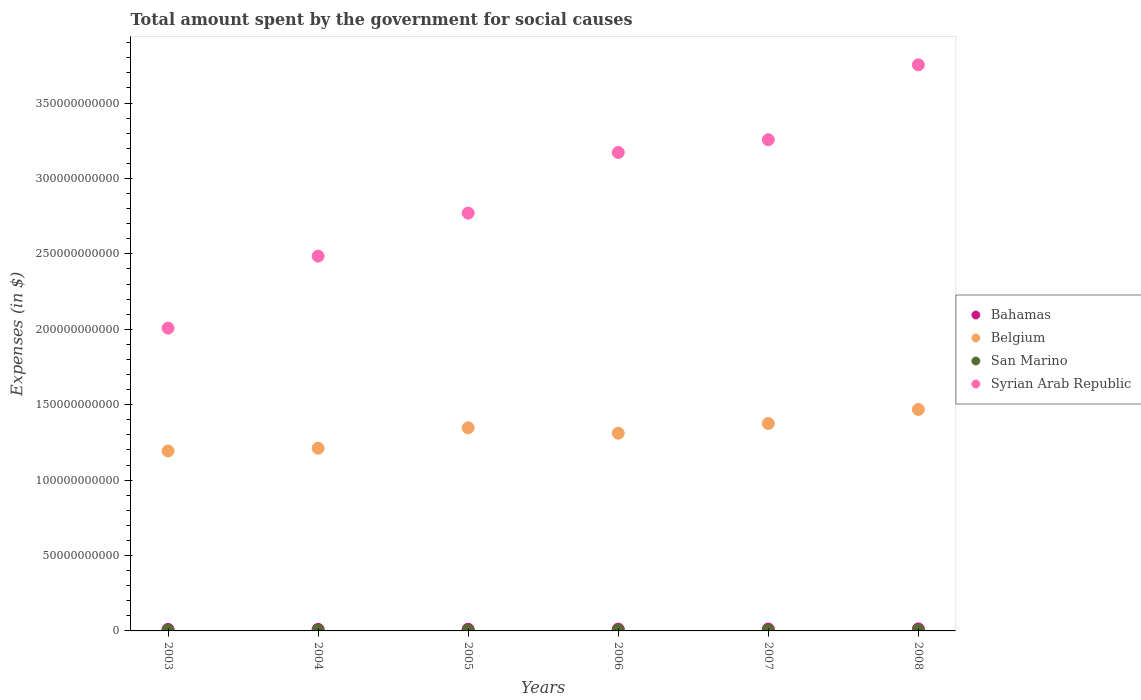How many different coloured dotlines are there?
Offer a terse response. 4. Is the number of dotlines equal to the number of legend labels?
Offer a very short reply. Yes. What is the amount spent for social causes by the government in Bahamas in 2004?
Provide a succinct answer. 1.02e+09. Across all years, what is the maximum amount spent for social causes by the government in Syrian Arab Republic?
Provide a short and direct response. 3.75e+11. Across all years, what is the minimum amount spent for social causes by the government in San Marino?
Your answer should be compact. 4.07e+08. What is the total amount spent for social causes by the government in Belgium in the graph?
Provide a succinct answer. 7.91e+11. What is the difference between the amount spent for social causes by the government in Syrian Arab Republic in 2005 and that in 2006?
Your response must be concise. -4.02e+1. What is the difference between the amount spent for social causes by the government in Bahamas in 2004 and the amount spent for social causes by the government in Syrian Arab Republic in 2005?
Offer a terse response. -2.76e+11. What is the average amount spent for social causes by the government in Bahamas per year?
Offer a terse response. 1.15e+09. In the year 2006, what is the difference between the amount spent for social causes by the government in Syrian Arab Republic and amount spent for social causes by the government in Bahamas?
Your response must be concise. 3.16e+11. What is the ratio of the amount spent for social causes by the government in Bahamas in 2003 to that in 2004?
Make the answer very short. 0.98. Is the amount spent for social causes by the government in Syrian Arab Republic in 2003 less than that in 2007?
Provide a succinct answer. Yes. Is the difference between the amount spent for social causes by the government in Syrian Arab Republic in 2003 and 2007 greater than the difference between the amount spent for social causes by the government in Bahamas in 2003 and 2007?
Make the answer very short. No. What is the difference between the highest and the second highest amount spent for social causes by the government in Syrian Arab Republic?
Provide a short and direct response. 4.96e+1. What is the difference between the highest and the lowest amount spent for social causes by the government in Syrian Arab Republic?
Provide a short and direct response. 1.75e+11. In how many years, is the amount spent for social causes by the government in Bahamas greater than the average amount spent for social causes by the government in Bahamas taken over all years?
Provide a succinct answer. 3. Is it the case that in every year, the sum of the amount spent for social causes by the government in Bahamas and amount spent for social causes by the government in Belgium  is greater than the sum of amount spent for social causes by the government in Syrian Arab Republic and amount spent for social causes by the government in San Marino?
Keep it short and to the point. Yes. Is it the case that in every year, the sum of the amount spent for social causes by the government in Bahamas and amount spent for social causes by the government in Syrian Arab Republic  is greater than the amount spent for social causes by the government in Belgium?
Your answer should be very brief. Yes. Does the amount spent for social causes by the government in Syrian Arab Republic monotonically increase over the years?
Give a very brief answer. Yes. Is the amount spent for social causes by the government in San Marino strictly less than the amount spent for social causes by the government in Belgium over the years?
Provide a short and direct response. Yes. How many dotlines are there?
Ensure brevity in your answer.  4. Are the values on the major ticks of Y-axis written in scientific E-notation?
Your answer should be very brief. No. Does the graph contain any zero values?
Your response must be concise. No. Does the graph contain grids?
Offer a very short reply. No. Where does the legend appear in the graph?
Make the answer very short. Center right. What is the title of the graph?
Offer a terse response. Total amount spent by the government for social causes. Does "Senegal" appear as one of the legend labels in the graph?
Offer a terse response. No. What is the label or title of the Y-axis?
Your answer should be very brief. Expenses (in $). What is the Expenses (in $) of Bahamas in 2003?
Ensure brevity in your answer.  9.99e+08. What is the Expenses (in $) in Belgium in 2003?
Ensure brevity in your answer.  1.19e+11. What is the Expenses (in $) in San Marino in 2003?
Provide a short and direct response. 4.07e+08. What is the Expenses (in $) in Syrian Arab Republic in 2003?
Your answer should be very brief. 2.01e+11. What is the Expenses (in $) in Bahamas in 2004?
Your answer should be compact. 1.02e+09. What is the Expenses (in $) in Belgium in 2004?
Provide a succinct answer. 1.21e+11. What is the Expenses (in $) of San Marino in 2004?
Give a very brief answer. 4.59e+08. What is the Expenses (in $) in Syrian Arab Republic in 2004?
Provide a succinct answer. 2.48e+11. What is the Expenses (in $) in Bahamas in 2005?
Keep it short and to the point. 1.12e+09. What is the Expenses (in $) of Belgium in 2005?
Ensure brevity in your answer.  1.35e+11. What is the Expenses (in $) in San Marino in 2005?
Offer a very short reply. 4.33e+08. What is the Expenses (in $) of Syrian Arab Republic in 2005?
Offer a very short reply. 2.77e+11. What is the Expenses (in $) in Bahamas in 2006?
Provide a short and direct response. 1.19e+09. What is the Expenses (in $) of Belgium in 2006?
Make the answer very short. 1.31e+11. What is the Expenses (in $) of San Marino in 2006?
Your answer should be very brief. 4.46e+08. What is the Expenses (in $) of Syrian Arab Republic in 2006?
Offer a very short reply. 3.17e+11. What is the Expenses (in $) of Bahamas in 2007?
Provide a succinct answer. 1.26e+09. What is the Expenses (in $) of Belgium in 2007?
Ensure brevity in your answer.  1.38e+11. What is the Expenses (in $) in San Marino in 2007?
Provide a succinct answer. 4.86e+08. What is the Expenses (in $) in Syrian Arab Republic in 2007?
Offer a terse response. 3.26e+11. What is the Expenses (in $) of Bahamas in 2008?
Your answer should be very brief. 1.34e+09. What is the Expenses (in $) of Belgium in 2008?
Make the answer very short. 1.47e+11. What is the Expenses (in $) of San Marino in 2008?
Your answer should be very brief. 5.02e+08. What is the Expenses (in $) of Syrian Arab Republic in 2008?
Offer a terse response. 3.75e+11. Across all years, what is the maximum Expenses (in $) in Bahamas?
Offer a terse response. 1.34e+09. Across all years, what is the maximum Expenses (in $) in Belgium?
Ensure brevity in your answer.  1.47e+11. Across all years, what is the maximum Expenses (in $) in San Marino?
Your response must be concise. 5.02e+08. Across all years, what is the maximum Expenses (in $) in Syrian Arab Republic?
Offer a terse response. 3.75e+11. Across all years, what is the minimum Expenses (in $) in Bahamas?
Ensure brevity in your answer.  9.99e+08. Across all years, what is the minimum Expenses (in $) of Belgium?
Offer a terse response. 1.19e+11. Across all years, what is the minimum Expenses (in $) of San Marino?
Your answer should be very brief. 4.07e+08. Across all years, what is the minimum Expenses (in $) of Syrian Arab Republic?
Provide a succinct answer. 2.01e+11. What is the total Expenses (in $) in Bahamas in the graph?
Keep it short and to the point. 6.93e+09. What is the total Expenses (in $) of Belgium in the graph?
Offer a terse response. 7.91e+11. What is the total Expenses (in $) of San Marino in the graph?
Keep it short and to the point. 2.73e+09. What is the total Expenses (in $) in Syrian Arab Republic in the graph?
Provide a short and direct response. 1.74e+12. What is the difference between the Expenses (in $) of Bahamas in 2003 and that in 2004?
Provide a short and direct response. -2.23e+07. What is the difference between the Expenses (in $) of Belgium in 2003 and that in 2004?
Make the answer very short. -1.83e+09. What is the difference between the Expenses (in $) in San Marino in 2003 and that in 2004?
Ensure brevity in your answer.  -5.16e+07. What is the difference between the Expenses (in $) of Syrian Arab Republic in 2003 and that in 2004?
Ensure brevity in your answer.  -4.77e+1. What is the difference between the Expenses (in $) of Bahamas in 2003 and that in 2005?
Provide a short and direct response. -1.18e+08. What is the difference between the Expenses (in $) of Belgium in 2003 and that in 2005?
Provide a succinct answer. -1.54e+1. What is the difference between the Expenses (in $) in San Marino in 2003 and that in 2005?
Offer a terse response. -2.59e+07. What is the difference between the Expenses (in $) in Syrian Arab Republic in 2003 and that in 2005?
Offer a very short reply. -7.63e+1. What is the difference between the Expenses (in $) in Bahamas in 2003 and that in 2006?
Keep it short and to the point. -1.87e+08. What is the difference between the Expenses (in $) of Belgium in 2003 and that in 2006?
Offer a very short reply. -1.18e+1. What is the difference between the Expenses (in $) in San Marino in 2003 and that in 2006?
Make the answer very short. -3.85e+07. What is the difference between the Expenses (in $) of Syrian Arab Republic in 2003 and that in 2006?
Make the answer very short. -1.16e+11. What is the difference between the Expenses (in $) in Bahamas in 2003 and that in 2007?
Offer a very short reply. -2.61e+08. What is the difference between the Expenses (in $) of Belgium in 2003 and that in 2007?
Ensure brevity in your answer.  -1.82e+1. What is the difference between the Expenses (in $) of San Marino in 2003 and that in 2007?
Provide a short and direct response. -7.90e+07. What is the difference between the Expenses (in $) of Syrian Arab Republic in 2003 and that in 2007?
Provide a succinct answer. -1.25e+11. What is the difference between the Expenses (in $) of Bahamas in 2003 and that in 2008?
Your response must be concise. -3.46e+08. What is the difference between the Expenses (in $) in Belgium in 2003 and that in 2008?
Make the answer very short. -2.75e+1. What is the difference between the Expenses (in $) of San Marino in 2003 and that in 2008?
Your answer should be very brief. -9.46e+07. What is the difference between the Expenses (in $) in Syrian Arab Republic in 2003 and that in 2008?
Give a very brief answer. -1.75e+11. What is the difference between the Expenses (in $) of Bahamas in 2004 and that in 2005?
Your answer should be compact. -9.59e+07. What is the difference between the Expenses (in $) in Belgium in 2004 and that in 2005?
Provide a short and direct response. -1.36e+1. What is the difference between the Expenses (in $) in San Marino in 2004 and that in 2005?
Provide a succinct answer. 2.57e+07. What is the difference between the Expenses (in $) in Syrian Arab Republic in 2004 and that in 2005?
Your answer should be compact. -2.85e+1. What is the difference between the Expenses (in $) in Bahamas in 2004 and that in 2006?
Your answer should be compact. -1.65e+08. What is the difference between the Expenses (in $) of Belgium in 2004 and that in 2006?
Ensure brevity in your answer.  -9.96e+09. What is the difference between the Expenses (in $) in San Marino in 2004 and that in 2006?
Your answer should be compact. 1.31e+07. What is the difference between the Expenses (in $) in Syrian Arab Republic in 2004 and that in 2006?
Your answer should be compact. -6.87e+1. What is the difference between the Expenses (in $) in Bahamas in 2004 and that in 2007?
Your answer should be compact. -2.39e+08. What is the difference between the Expenses (in $) of Belgium in 2004 and that in 2007?
Offer a very short reply. -1.64e+1. What is the difference between the Expenses (in $) in San Marino in 2004 and that in 2007?
Your answer should be compact. -2.74e+07. What is the difference between the Expenses (in $) of Syrian Arab Republic in 2004 and that in 2007?
Your response must be concise. -7.72e+1. What is the difference between the Expenses (in $) of Bahamas in 2004 and that in 2008?
Give a very brief answer. -3.24e+08. What is the difference between the Expenses (in $) of Belgium in 2004 and that in 2008?
Keep it short and to the point. -2.57e+1. What is the difference between the Expenses (in $) of San Marino in 2004 and that in 2008?
Make the answer very short. -4.31e+07. What is the difference between the Expenses (in $) in Syrian Arab Republic in 2004 and that in 2008?
Your response must be concise. -1.27e+11. What is the difference between the Expenses (in $) of Bahamas in 2005 and that in 2006?
Provide a short and direct response. -6.87e+07. What is the difference between the Expenses (in $) of Belgium in 2005 and that in 2006?
Give a very brief answer. 3.59e+09. What is the difference between the Expenses (in $) in San Marino in 2005 and that in 2006?
Make the answer very short. -1.26e+07. What is the difference between the Expenses (in $) in Syrian Arab Republic in 2005 and that in 2006?
Your answer should be compact. -4.02e+1. What is the difference between the Expenses (in $) of Bahamas in 2005 and that in 2007?
Your answer should be compact. -1.43e+08. What is the difference between the Expenses (in $) in Belgium in 2005 and that in 2007?
Your response must be concise. -2.83e+09. What is the difference between the Expenses (in $) of San Marino in 2005 and that in 2007?
Your answer should be compact. -5.31e+07. What is the difference between the Expenses (in $) of Syrian Arab Republic in 2005 and that in 2007?
Offer a terse response. -4.87e+1. What is the difference between the Expenses (in $) of Bahamas in 2005 and that in 2008?
Offer a terse response. -2.28e+08. What is the difference between the Expenses (in $) of Belgium in 2005 and that in 2008?
Ensure brevity in your answer.  -1.21e+1. What is the difference between the Expenses (in $) in San Marino in 2005 and that in 2008?
Your answer should be very brief. -6.88e+07. What is the difference between the Expenses (in $) of Syrian Arab Republic in 2005 and that in 2008?
Provide a succinct answer. -9.83e+1. What is the difference between the Expenses (in $) of Bahamas in 2006 and that in 2007?
Make the answer very short. -7.43e+07. What is the difference between the Expenses (in $) in Belgium in 2006 and that in 2007?
Make the answer very short. -6.42e+09. What is the difference between the Expenses (in $) in San Marino in 2006 and that in 2007?
Make the answer very short. -4.05e+07. What is the difference between the Expenses (in $) of Syrian Arab Republic in 2006 and that in 2007?
Make the answer very short. -8.48e+09. What is the difference between the Expenses (in $) of Bahamas in 2006 and that in 2008?
Your response must be concise. -1.59e+08. What is the difference between the Expenses (in $) of Belgium in 2006 and that in 2008?
Provide a short and direct response. -1.57e+1. What is the difference between the Expenses (in $) in San Marino in 2006 and that in 2008?
Ensure brevity in your answer.  -5.62e+07. What is the difference between the Expenses (in $) of Syrian Arab Republic in 2006 and that in 2008?
Give a very brief answer. -5.81e+1. What is the difference between the Expenses (in $) in Bahamas in 2007 and that in 2008?
Your answer should be compact. -8.48e+07. What is the difference between the Expenses (in $) in Belgium in 2007 and that in 2008?
Keep it short and to the point. -9.32e+09. What is the difference between the Expenses (in $) in San Marino in 2007 and that in 2008?
Provide a succinct answer. -1.57e+07. What is the difference between the Expenses (in $) of Syrian Arab Republic in 2007 and that in 2008?
Provide a short and direct response. -4.96e+1. What is the difference between the Expenses (in $) in Bahamas in 2003 and the Expenses (in $) in Belgium in 2004?
Give a very brief answer. -1.20e+11. What is the difference between the Expenses (in $) of Bahamas in 2003 and the Expenses (in $) of San Marino in 2004?
Your response must be concise. 5.40e+08. What is the difference between the Expenses (in $) of Bahamas in 2003 and the Expenses (in $) of Syrian Arab Republic in 2004?
Your answer should be compact. -2.47e+11. What is the difference between the Expenses (in $) in Belgium in 2003 and the Expenses (in $) in San Marino in 2004?
Your answer should be compact. 1.19e+11. What is the difference between the Expenses (in $) in Belgium in 2003 and the Expenses (in $) in Syrian Arab Republic in 2004?
Make the answer very short. -1.29e+11. What is the difference between the Expenses (in $) in San Marino in 2003 and the Expenses (in $) in Syrian Arab Republic in 2004?
Your answer should be compact. -2.48e+11. What is the difference between the Expenses (in $) of Bahamas in 2003 and the Expenses (in $) of Belgium in 2005?
Provide a short and direct response. -1.34e+11. What is the difference between the Expenses (in $) of Bahamas in 2003 and the Expenses (in $) of San Marino in 2005?
Offer a terse response. 5.66e+08. What is the difference between the Expenses (in $) in Bahamas in 2003 and the Expenses (in $) in Syrian Arab Republic in 2005?
Keep it short and to the point. -2.76e+11. What is the difference between the Expenses (in $) in Belgium in 2003 and the Expenses (in $) in San Marino in 2005?
Your response must be concise. 1.19e+11. What is the difference between the Expenses (in $) of Belgium in 2003 and the Expenses (in $) of Syrian Arab Republic in 2005?
Give a very brief answer. -1.58e+11. What is the difference between the Expenses (in $) in San Marino in 2003 and the Expenses (in $) in Syrian Arab Republic in 2005?
Your answer should be very brief. -2.77e+11. What is the difference between the Expenses (in $) of Bahamas in 2003 and the Expenses (in $) of Belgium in 2006?
Ensure brevity in your answer.  -1.30e+11. What is the difference between the Expenses (in $) of Bahamas in 2003 and the Expenses (in $) of San Marino in 2006?
Your answer should be compact. 5.53e+08. What is the difference between the Expenses (in $) of Bahamas in 2003 and the Expenses (in $) of Syrian Arab Republic in 2006?
Ensure brevity in your answer.  -3.16e+11. What is the difference between the Expenses (in $) of Belgium in 2003 and the Expenses (in $) of San Marino in 2006?
Your answer should be compact. 1.19e+11. What is the difference between the Expenses (in $) in Belgium in 2003 and the Expenses (in $) in Syrian Arab Republic in 2006?
Keep it short and to the point. -1.98e+11. What is the difference between the Expenses (in $) of San Marino in 2003 and the Expenses (in $) of Syrian Arab Republic in 2006?
Provide a short and direct response. -3.17e+11. What is the difference between the Expenses (in $) in Bahamas in 2003 and the Expenses (in $) in Belgium in 2007?
Your response must be concise. -1.37e+11. What is the difference between the Expenses (in $) in Bahamas in 2003 and the Expenses (in $) in San Marino in 2007?
Offer a terse response. 5.13e+08. What is the difference between the Expenses (in $) in Bahamas in 2003 and the Expenses (in $) in Syrian Arab Republic in 2007?
Your answer should be compact. -3.25e+11. What is the difference between the Expenses (in $) of Belgium in 2003 and the Expenses (in $) of San Marino in 2007?
Provide a succinct answer. 1.19e+11. What is the difference between the Expenses (in $) in Belgium in 2003 and the Expenses (in $) in Syrian Arab Republic in 2007?
Make the answer very short. -2.06e+11. What is the difference between the Expenses (in $) in San Marino in 2003 and the Expenses (in $) in Syrian Arab Republic in 2007?
Ensure brevity in your answer.  -3.25e+11. What is the difference between the Expenses (in $) of Bahamas in 2003 and the Expenses (in $) of Belgium in 2008?
Give a very brief answer. -1.46e+11. What is the difference between the Expenses (in $) in Bahamas in 2003 and the Expenses (in $) in San Marino in 2008?
Make the answer very short. 4.97e+08. What is the difference between the Expenses (in $) in Bahamas in 2003 and the Expenses (in $) in Syrian Arab Republic in 2008?
Provide a short and direct response. -3.74e+11. What is the difference between the Expenses (in $) of Belgium in 2003 and the Expenses (in $) of San Marino in 2008?
Make the answer very short. 1.19e+11. What is the difference between the Expenses (in $) in Belgium in 2003 and the Expenses (in $) in Syrian Arab Republic in 2008?
Provide a short and direct response. -2.56e+11. What is the difference between the Expenses (in $) in San Marino in 2003 and the Expenses (in $) in Syrian Arab Republic in 2008?
Make the answer very short. -3.75e+11. What is the difference between the Expenses (in $) of Bahamas in 2004 and the Expenses (in $) of Belgium in 2005?
Offer a terse response. -1.34e+11. What is the difference between the Expenses (in $) of Bahamas in 2004 and the Expenses (in $) of San Marino in 2005?
Provide a succinct answer. 5.88e+08. What is the difference between the Expenses (in $) in Bahamas in 2004 and the Expenses (in $) in Syrian Arab Republic in 2005?
Offer a terse response. -2.76e+11. What is the difference between the Expenses (in $) of Belgium in 2004 and the Expenses (in $) of San Marino in 2005?
Provide a succinct answer. 1.21e+11. What is the difference between the Expenses (in $) in Belgium in 2004 and the Expenses (in $) in Syrian Arab Republic in 2005?
Make the answer very short. -1.56e+11. What is the difference between the Expenses (in $) in San Marino in 2004 and the Expenses (in $) in Syrian Arab Republic in 2005?
Your response must be concise. -2.77e+11. What is the difference between the Expenses (in $) in Bahamas in 2004 and the Expenses (in $) in Belgium in 2006?
Your response must be concise. -1.30e+11. What is the difference between the Expenses (in $) of Bahamas in 2004 and the Expenses (in $) of San Marino in 2006?
Provide a short and direct response. 5.76e+08. What is the difference between the Expenses (in $) of Bahamas in 2004 and the Expenses (in $) of Syrian Arab Republic in 2006?
Make the answer very short. -3.16e+11. What is the difference between the Expenses (in $) in Belgium in 2004 and the Expenses (in $) in San Marino in 2006?
Provide a short and direct response. 1.21e+11. What is the difference between the Expenses (in $) of Belgium in 2004 and the Expenses (in $) of Syrian Arab Republic in 2006?
Provide a short and direct response. -1.96e+11. What is the difference between the Expenses (in $) of San Marino in 2004 and the Expenses (in $) of Syrian Arab Republic in 2006?
Provide a succinct answer. -3.17e+11. What is the difference between the Expenses (in $) in Bahamas in 2004 and the Expenses (in $) in Belgium in 2007?
Ensure brevity in your answer.  -1.36e+11. What is the difference between the Expenses (in $) of Bahamas in 2004 and the Expenses (in $) of San Marino in 2007?
Provide a short and direct response. 5.35e+08. What is the difference between the Expenses (in $) of Bahamas in 2004 and the Expenses (in $) of Syrian Arab Republic in 2007?
Provide a succinct answer. -3.25e+11. What is the difference between the Expenses (in $) in Belgium in 2004 and the Expenses (in $) in San Marino in 2007?
Provide a short and direct response. 1.21e+11. What is the difference between the Expenses (in $) in Belgium in 2004 and the Expenses (in $) in Syrian Arab Republic in 2007?
Give a very brief answer. -2.05e+11. What is the difference between the Expenses (in $) of San Marino in 2004 and the Expenses (in $) of Syrian Arab Republic in 2007?
Offer a very short reply. -3.25e+11. What is the difference between the Expenses (in $) in Bahamas in 2004 and the Expenses (in $) in Belgium in 2008?
Your answer should be very brief. -1.46e+11. What is the difference between the Expenses (in $) in Bahamas in 2004 and the Expenses (in $) in San Marino in 2008?
Your answer should be compact. 5.19e+08. What is the difference between the Expenses (in $) in Bahamas in 2004 and the Expenses (in $) in Syrian Arab Republic in 2008?
Keep it short and to the point. -3.74e+11. What is the difference between the Expenses (in $) of Belgium in 2004 and the Expenses (in $) of San Marino in 2008?
Provide a succinct answer. 1.21e+11. What is the difference between the Expenses (in $) of Belgium in 2004 and the Expenses (in $) of Syrian Arab Republic in 2008?
Provide a short and direct response. -2.54e+11. What is the difference between the Expenses (in $) in San Marino in 2004 and the Expenses (in $) in Syrian Arab Republic in 2008?
Your answer should be compact. -3.75e+11. What is the difference between the Expenses (in $) in Bahamas in 2005 and the Expenses (in $) in Belgium in 2006?
Provide a short and direct response. -1.30e+11. What is the difference between the Expenses (in $) of Bahamas in 2005 and the Expenses (in $) of San Marino in 2006?
Your answer should be compact. 6.71e+08. What is the difference between the Expenses (in $) of Bahamas in 2005 and the Expenses (in $) of Syrian Arab Republic in 2006?
Your answer should be compact. -3.16e+11. What is the difference between the Expenses (in $) of Belgium in 2005 and the Expenses (in $) of San Marino in 2006?
Your answer should be compact. 1.34e+11. What is the difference between the Expenses (in $) of Belgium in 2005 and the Expenses (in $) of Syrian Arab Republic in 2006?
Offer a very short reply. -1.83e+11. What is the difference between the Expenses (in $) in San Marino in 2005 and the Expenses (in $) in Syrian Arab Republic in 2006?
Provide a short and direct response. -3.17e+11. What is the difference between the Expenses (in $) of Bahamas in 2005 and the Expenses (in $) of Belgium in 2007?
Keep it short and to the point. -1.36e+11. What is the difference between the Expenses (in $) of Bahamas in 2005 and the Expenses (in $) of San Marino in 2007?
Your answer should be compact. 6.31e+08. What is the difference between the Expenses (in $) in Bahamas in 2005 and the Expenses (in $) in Syrian Arab Republic in 2007?
Offer a very short reply. -3.25e+11. What is the difference between the Expenses (in $) in Belgium in 2005 and the Expenses (in $) in San Marino in 2007?
Offer a very short reply. 1.34e+11. What is the difference between the Expenses (in $) of Belgium in 2005 and the Expenses (in $) of Syrian Arab Republic in 2007?
Ensure brevity in your answer.  -1.91e+11. What is the difference between the Expenses (in $) in San Marino in 2005 and the Expenses (in $) in Syrian Arab Republic in 2007?
Make the answer very short. -3.25e+11. What is the difference between the Expenses (in $) of Bahamas in 2005 and the Expenses (in $) of Belgium in 2008?
Give a very brief answer. -1.46e+11. What is the difference between the Expenses (in $) in Bahamas in 2005 and the Expenses (in $) in San Marino in 2008?
Provide a short and direct response. 6.15e+08. What is the difference between the Expenses (in $) in Bahamas in 2005 and the Expenses (in $) in Syrian Arab Republic in 2008?
Give a very brief answer. -3.74e+11. What is the difference between the Expenses (in $) in Belgium in 2005 and the Expenses (in $) in San Marino in 2008?
Give a very brief answer. 1.34e+11. What is the difference between the Expenses (in $) in Belgium in 2005 and the Expenses (in $) in Syrian Arab Republic in 2008?
Keep it short and to the point. -2.41e+11. What is the difference between the Expenses (in $) of San Marino in 2005 and the Expenses (in $) of Syrian Arab Republic in 2008?
Provide a short and direct response. -3.75e+11. What is the difference between the Expenses (in $) in Bahamas in 2006 and the Expenses (in $) in Belgium in 2007?
Offer a terse response. -1.36e+11. What is the difference between the Expenses (in $) of Bahamas in 2006 and the Expenses (in $) of San Marino in 2007?
Your answer should be compact. 7.00e+08. What is the difference between the Expenses (in $) of Bahamas in 2006 and the Expenses (in $) of Syrian Arab Republic in 2007?
Your answer should be compact. -3.25e+11. What is the difference between the Expenses (in $) in Belgium in 2006 and the Expenses (in $) in San Marino in 2007?
Your answer should be compact. 1.31e+11. What is the difference between the Expenses (in $) of Belgium in 2006 and the Expenses (in $) of Syrian Arab Republic in 2007?
Provide a succinct answer. -1.95e+11. What is the difference between the Expenses (in $) of San Marino in 2006 and the Expenses (in $) of Syrian Arab Republic in 2007?
Your answer should be very brief. -3.25e+11. What is the difference between the Expenses (in $) in Bahamas in 2006 and the Expenses (in $) in Belgium in 2008?
Offer a terse response. -1.46e+11. What is the difference between the Expenses (in $) in Bahamas in 2006 and the Expenses (in $) in San Marino in 2008?
Make the answer very short. 6.84e+08. What is the difference between the Expenses (in $) of Bahamas in 2006 and the Expenses (in $) of Syrian Arab Republic in 2008?
Give a very brief answer. -3.74e+11. What is the difference between the Expenses (in $) of Belgium in 2006 and the Expenses (in $) of San Marino in 2008?
Offer a very short reply. 1.31e+11. What is the difference between the Expenses (in $) of Belgium in 2006 and the Expenses (in $) of Syrian Arab Republic in 2008?
Ensure brevity in your answer.  -2.44e+11. What is the difference between the Expenses (in $) of San Marino in 2006 and the Expenses (in $) of Syrian Arab Republic in 2008?
Provide a short and direct response. -3.75e+11. What is the difference between the Expenses (in $) of Bahamas in 2007 and the Expenses (in $) of Belgium in 2008?
Ensure brevity in your answer.  -1.46e+11. What is the difference between the Expenses (in $) of Bahamas in 2007 and the Expenses (in $) of San Marino in 2008?
Ensure brevity in your answer.  7.58e+08. What is the difference between the Expenses (in $) of Bahamas in 2007 and the Expenses (in $) of Syrian Arab Republic in 2008?
Keep it short and to the point. -3.74e+11. What is the difference between the Expenses (in $) in Belgium in 2007 and the Expenses (in $) in San Marino in 2008?
Ensure brevity in your answer.  1.37e+11. What is the difference between the Expenses (in $) of Belgium in 2007 and the Expenses (in $) of Syrian Arab Republic in 2008?
Provide a short and direct response. -2.38e+11. What is the difference between the Expenses (in $) in San Marino in 2007 and the Expenses (in $) in Syrian Arab Republic in 2008?
Make the answer very short. -3.75e+11. What is the average Expenses (in $) in Bahamas per year?
Provide a succinct answer. 1.15e+09. What is the average Expenses (in $) of Belgium per year?
Provide a short and direct response. 1.32e+11. What is the average Expenses (in $) of San Marino per year?
Your answer should be very brief. 4.55e+08. What is the average Expenses (in $) in Syrian Arab Republic per year?
Your answer should be very brief. 2.91e+11. In the year 2003, what is the difference between the Expenses (in $) of Bahamas and Expenses (in $) of Belgium?
Provide a short and direct response. -1.18e+11. In the year 2003, what is the difference between the Expenses (in $) of Bahamas and Expenses (in $) of San Marino?
Provide a succinct answer. 5.92e+08. In the year 2003, what is the difference between the Expenses (in $) in Bahamas and Expenses (in $) in Syrian Arab Republic?
Your answer should be compact. -2.00e+11. In the year 2003, what is the difference between the Expenses (in $) of Belgium and Expenses (in $) of San Marino?
Your answer should be compact. 1.19e+11. In the year 2003, what is the difference between the Expenses (in $) of Belgium and Expenses (in $) of Syrian Arab Republic?
Your answer should be compact. -8.15e+1. In the year 2003, what is the difference between the Expenses (in $) of San Marino and Expenses (in $) of Syrian Arab Republic?
Ensure brevity in your answer.  -2.00e+11. In the year 2004, what is the difference between the Expenses (in $) in Bahamas and Expenses (in $) in Belgium?
Provide a short and direct response. -1.20e+11. In the year 2004, what is the difference between the Expenses (in $) of Bahamas and Expenses (in $) of San Marino?
Your response must be concise. 5.62e+08. In the year 2004, what is the difference between the Expenses (in $) in Bahamas and Expenses (in $) in Syrian Arab Republic?
Offer a very short reply. -2.47e+11. In the year 2004, what is the difference between the Expenses (in $) of Belgium and Expenses (in $) of San Marino?
Give a very brief answer. 1.21e+11. In the year 2004, what is the difference between the Expenses (in $) in Belgium and Expenses (in $) in Syrian Arab Republic?
Your response must be concise. -1.27e+11. In the year 2004, what is the difference between the Expenses (in $) of San Marino and Expenses (in $) of Syrian Arab Republic?
Give a very brief answer. -2.48e+11. In the year 2005, what is the difference between the Expenses (in $) in Bahamas and Expenses (in $) in Belgium?
Make the answer very short. -1.34e+11. In the year 2005, what is the difference between the Expenses (in $) in Bahamas and Expenses (in $) in San Marino?
Your answer should be very brief. 6.84e+08. In the year 2005, what is the difference between the Expenses (in $) in Bahamas and Expenses (in $) in Syrian Arab Republic?
Your response must be concise. -2.76e+11. In the year 2005, what is the difference between the Expenses (in $) in Belgium and Expenses (in $) in San Marino?
Provide a succinct answer. 1.34e+11. In the year 2005, what is the difference between the Expenses (in $) of Belgium and Expenses (in $) of Syrian Arab Republic?
Provide a succinct answer. -1.42e+11. In the year 2005, what is the difference between the Expenses (in $) in San Marino and Expenses (in $) in Syrian Arab Republic?
Offer a terse response. -2.77e+11. In the year 2006, what is the difference between the Expenses (in $) in Bahamas and Expenses (in $) in Belgium?
Provide a succinct answer. -1.30e+11. In the year 2006, what is the difference between the Expenses (in $) in Bahamas and Expenses (in $) in San Marino?
Make the answer very short. 7.40e+08. In the year 2006, what is the difference between the Expenses (in $) of Bahamas and Expenses (in $) of Syrian Arab Republic?
Provide a short and direct response. -3.16e+11. In the year 2006, what is the difference between the Expenses (in $) of Belgium and Expenses (in $) of San Marino?
Provide a short and direct response. 1.31e+11. In the year 2006, what is the difference between the Expenses (in $) of Belgium and Expenses (in $) of Syrian Arab Republic?
Your answer should be very brief. -1.86e+11. In the year 2006, what is the difference between the Expenses (in $) of San Marino and Expenses (in $) of Syrian Arab Republic?
Your response must be concise. -3.17e+11. In the year 2007, what is the difference between the Expenses (in $) of Bahamas and Expenses (in $) of Belgium?
Your answer should be very brief. -1.36e+11. In the year 2007, what is the difference between the Expenses (in $) of Bahamas and Expenses (in $) of San Marino?
Offer a terse response. 7.74e+08. In the year 2007, what is the difference between the Expenses (in $) of Bahamas and Expenses (in $) of Syrian Arab Republic?
Provide a short and direct response. -3.24e+11. In the year 2007, what is the difference between the Expenses (in $) of Belgium and Expenses (in $) of San Marino?
Your response must be concise. 1.37e+11. In the year 2007, what is the difference between the Expenses (in $) of Belgium and Expenses (in $) of Syrian Arab Republic?
Keep it short and to the point. -1.88e+11. In the year 2007, what is the difference between the Expenses (in $) of San Marino and Expenses (in $) of Syrian Arab Republic?
Provide a succinct answer. -3.25e+11. In the year 2008, what is the difference between the Expenses (in $) in Bahamas and Expenses (in $) in Belgium?
Offer a terse response. -1.45e+11. In the year 2008, what is the difference between the Expenses (in $) in Bahamas and Expenses (in $) in San Marino?
Provide a short and direct response. 8.43e+08. In the year 2008, what is the difference between the Expenses (in $) of Bahamas and Expenses (in $) of Syrian Arab Republic?
Ensure brevity in your answer.  -3.74e+11. In the year 2008, what is the difference between the Expenses (in $) in Belgium and Expenses (in $) in San Marino?
Ensure brevity in your answer.  1.46e+11. In the year 2008, what is the difference between the Expenses (in $) in Belgium and Expenses (in $) in Syrian Arab Republic?
Offer a terse response. -2.28e+11. In the year 2008, what is the difference between the Expenses (in $) of San Marino and Expenses (in $) of Syrian Arab Republic?
Your response must be concise. -3.75e+11. What is the ratio of the Expenses (in $) in Bahamas in 2003 to that in 2004?
Make the answer very short. 0.98. What is the ratio of the Expenses (in $) of Belgium in 2003 to that in 2004?
Give a very brief answer. 0.98. What is the ratio of the Expenses (in $) of San Marino in 2003 to that in 2004?
Your answer should be very brief. 0.89. What is the ratio of the Expenses (in $) of Syrian Arab Republic in 2003 to that in 2004?
Ensure brevity in your answer.  0.81. What is the ratio of the Expenses (in $) in Bahamas in 2003 to that in 2005?
Make the answer very short. 0.89. What is the ratio of the Expenses (in $) in Belgium in 2003 to that in 2005?
Offer a very short reply. 0.89. What is the ratio of the Expenses (in $) in San Marino in 2003 to that in 2005?
Make the answer very short. 0.94. What is the ratio of the Expenses (in $) of Syrian Arab Republic in 2003 to that in 2005?
Ensure brevity in your answer.  0.72. What is the ratio of the Expenses (in $) of Bahamas in 2003 to that in 2006?
Provide a short and direct response. 0.84. What is the ratio of the Expenses (in $) in Belgium in 2003 to that in 2006?
Offer a very short reply. 0.91. What is the ratio of the Expenses (in $) of San Marino in 2003 to that in 2006?
Your answer should be compact. 0.91. What is the ratio of the Expenses (in $) of Syrian Arab Republic in 2003 to that in 2006?
Your answer should be very brief. 0.63. What is the ratio of the Expenses (in $) in Bahamas in 2003 to that in 2007?
Your answer should be very brief. 0.79. What is the ratio of the Expenses (in $) in Belgium in 2003 to that in 2007?
Make the answer very short. 0.87. What is the ratio of the Expenses (in $) of San Marino in 2003 to that in 2007?
Ensure brevity in your answer.  0.84. What is the ratio of the Expenses (in $) in Syrian Arab Republic in 2003 to that in 2007?
Your answer should be compact. 0.62. What is the ratio of the Expenses (in $) of Bahamas in 2003 to that in 2008?
Provide a short and direct response. 0.74. What is the ratio of the Expenses (in $) in Belgium in 2003 to that in 2008?
Offer a terse response. 0.81. What is the ratio of the Expenses (in $) in San Marino in 2003 to that in 2008?
Your response must be concise. 0.81. What is the ratio of the Expenses (in $) of Syrian Arab Republic in 2003 to that in 2008?
Provide a succinct answer. 0.53. What is the ratio of the Expenses (in $) of Bahamas in 2004 to that in 2005?
Your response must be concise. 0.91. What is the ratio of the Expenses (in $) in Belgium in 2004 to that in 2005?
Keep it short and to the point. 0.9. What is the ratio of the Expenses (in $) in San Marino in 2004 to that in 2005?
Offer a terse response. 1.06. What is the ratio of the Expenses (in $) of Syrian Arab Republic in 2004 to that in 2005?
Your answer should be very brief. 0.9. What is the ratio of the Expenses (in $) of Bahamas in 2004 to that in 2006?
Provide a short and direct response. 0.86. What is the ratio of the Expenses (in $) of Belgium in 2004 to that in 2006?
Provide a short and direct response. 0.92. What is the ratio of the Expenses (in $) in San Marino in 2004 to that in 2006?
Make the answer very short. 1.03. What is the ratio of the Expenses (in $) in Syrian Arab Republic in 2004 to that in 2006?
Provide a short and direct response. 0.78. What is the ratio of the Expenses (in $) of Bahamas in 2004 to that in 2007?
Your response must be concise. 0.81. What is the ratio of the Expenses (in $) of Belgium in 2004 to that in 2007?
Offer a very short reply. 0.88. What is the ratio of the Expenses (in $) of San Marino in 2004 to that in 2007?
Ensure brevity in your answer.  0.94. What is the ratio of the Expenses (in $) in Syrian Arab Republic in 2004 to that in 2007?
Give a very brief answer. 0.76. What is the ratio of the Expenses (in $) of Bahamas in 2004 to that in 2008?
Make the answer very short. 0.76. What is the ratio of the Expenses (in $) of Belgium in 2004 to that in 2008?
Provide a short and direct response. 0.82. What is the ratio of the Expenses (in $) of San Marino in 2004 to that in 2008?
Offer a very short reply. 0.91. What is the ratio of the Expenses (in $) of Syrian Arab Republic in 2004 to that in 2008?
Give a very brief answer. 0.66. What is the ratio of the Expenses (in $) of Bahamas in 2005 to that in 2006?
Ensure brevity in your answer.  0.94. What is the ratio of the Expenses (in $) of Belgium in 2005 to that in 2006?
Your answer should be compact. 1.03. What is the ratio of the Expenses (in $) in San Marino in 2005 to that in 2006?
Your answer should be compact. 0.97. What is the ratio of the Expenses (in $) of Syrian Arab Republic in 2005 to that in 2006?
Provide a short and direct response. 0.87. What is the ratio of the Expenses (in $) in Bahamas in 2005 to that in 2007?
Make the answer very short. 0.89. What is the ratio of the Expenses (in $) in Belgium in 2005 to that in 2007?
Offer a terse response. 0.98. What is the ratio of the Expenses (in $) of San Marino in 2005 to that in 2007?
Make the answer very short. 0.89. What is the ratio of the Expenses (in $) of Syrian Arab Republic in 2005 to that in 2007?
Provide a succinct answer. 0.85. What is the ratio of the Expenses (in $) in Bahamas in 2005 to that in 2008?
Ensure brevity in your answer.  0.83. What is the ratio of the Expenses (in $) of Belgium in 2005 to that in 2008?
Keep it short and to the point. 0.92. What is the ratio of the Expenses (in $) of San Marino in 2005 to that in 2008?
Your answer should be compact. 0.86. What is the ratio of the Expenses (in $) of Syrian Arab Republic in 2005 to that in 2008?
Your answer should be compact. 0.74. What is the ratio of the Expenses (in $) of Bahamas in 2006 to that in 2007?
Your response must be concise. 0.94. What is the ratio of the Expenses (in $) in Belgium in 2006 to that in 2007?
Keep it short and to the point. 0.95. What is the ratio of the Expenses (in $) of San Marino in 2006 to that in 2007?
Provide a short and direct response. 0.92. What is the ratio of the Expenses (in $) in Bahamas in 2006 to that in 2008?
Your answer should be compact. 0.88. What is the ratio of the Expenses (in $) of Belgium in 2006 to that in 2008?
Your answer should be very brief. 0.89. What is the ratio of the Expenses (in $) in San Marino in 2006 to that in 2008?
Give a very brief answer. 0.89. What is the ratio of the Expenses (in $) of Syrian Arab Republic in 2006 to that in 2008?
Offer a terse response. 0.85. What is the ratio of the Expenses (in $) of Bahamas in 2007 to that in 2008?
Offer a terse response. 0.94. What is the ratio of the Expenses (in $) of Belgium in 2007 to that in 2008?
Keep it short and to the point. 0.94. What is the ratio of the Expenses (in $) of San Marino in 2007 to that in 2008?
Keep it short and to the point. 0.97. What is the ratio of the Expenses (in $) of Syrian Arab Republic in 2007 to that in 2008?
Provide a short and direct response. 0.87. What is the difference between the highest and the second highest Expenses (in $) of Bahamas?
Provide a succinct answer. 8.48e+07. What is the difference between the highest and the second highest Expenses (in $) of Belgium?
Ensure brevity in your answer.  9.32e+09. What is the difference between the highest and the second highest Expenses (in $) of San Marino?
Your answer should be very brief. 1.57e+07. What is the difference between the highest and the second highest Expenses (in $) of Syrian Arab Republic?
Keep it short and to the point. 4.96e+1. What is the difference between the highest and the lowest Expenses (in $) in Bahamas?
Provide a succinct answer. 3.46e+08. What is the difference between the highest and the lowest Expenses (in $) of Belgium?
Offer a terse response. 2.75e+1. What is the difference between the highest and the lowest Expenses (in $) of San Marino?
Ensure brevity in your answer.  9.46e+07. What is the difference between the highest and the lowest Expenses (in $) of Syrian Arab Republic?
Provide a succinct answer. 1.75e+11. 